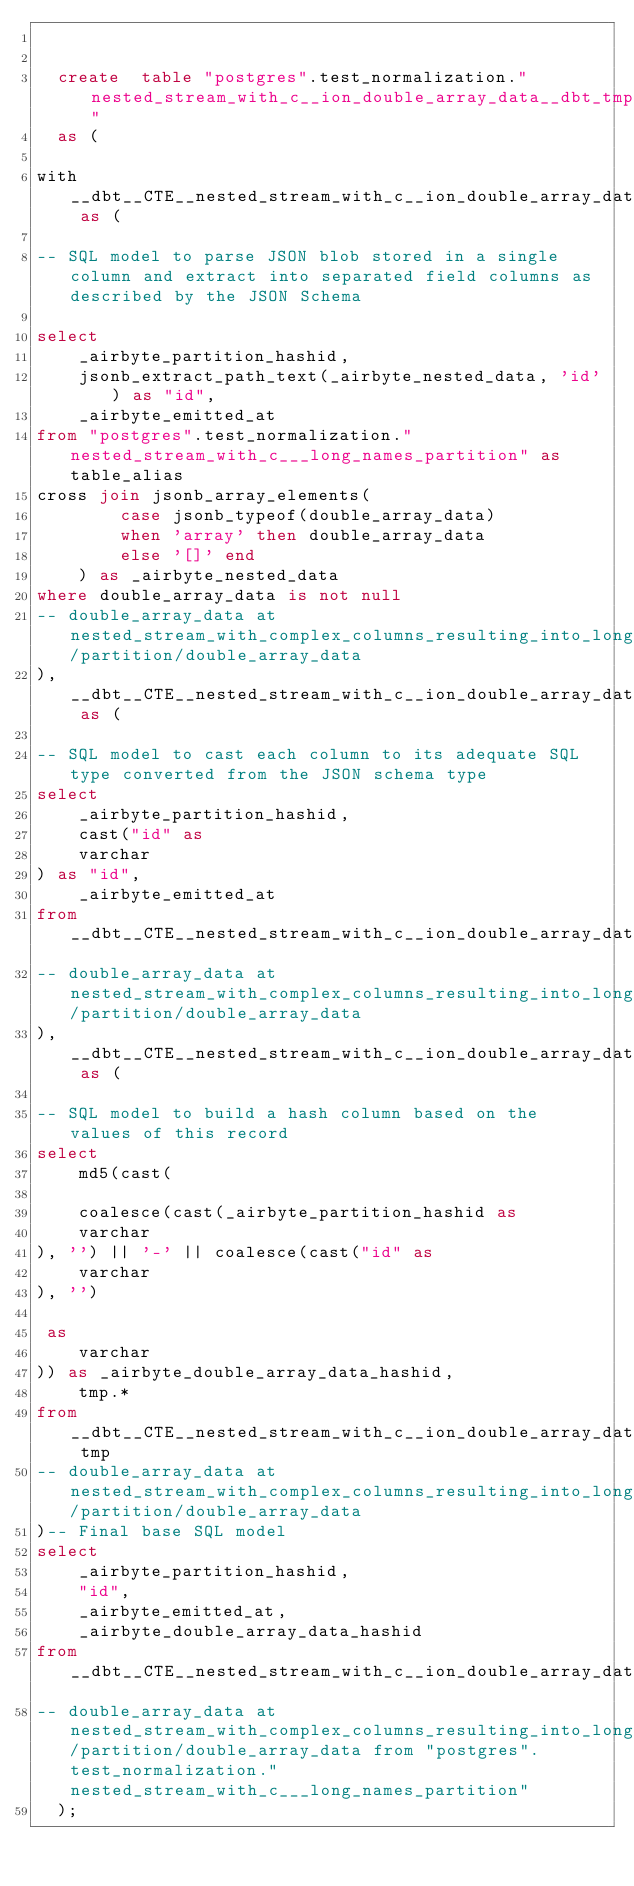<code> <loc_0><loc_0><loc_500><loc_500><_SQL_>

  create  table "postgres".test_normalization."nested_stream_with_c__ion_double_array_data__dbt_tmp"
  as (
    
with __dbt__CTE__nested_stream_with_c__ion_double_array_data_ab1 as (

-- SQL model to parse JSON blob stored in a single column and extract into separated field columns as described by the JSON Schema

select
    _airbyte_partition_hashid,
    jsonb_extract_path_text(_airbyte_nested_data, 'id') as "id",
    _airbyte_emitted_at
from "postgres".test_normalization."nested_stream_with_c___long_names_partition" as table_alias
cross join jsonb_array_elements(
        case jsonb_typeof(double_array_data)
        when 'array' then double_array_data
        else '[]' end
    ) as _airbyte_nested_data
where double_array_data is not null
-- double_array_data at nested_stream_with_complex_columns_resulting_into_long_names/partition/double_array_data
),  __dbt__CTE__nested_stream_with_c__ion_double_array_data_ab2 as (

-- SQL model to cast each column to its adequate SQL type converted from the JSON schema type
select
    _airbyte_partition_hashid,
    cast("id" as 
    varchar
) as "id",
    _airbyte_emitted_at
from __dbt__CTE__nested_stream_with_c__ion_double_array_data_ab1
-- double_array_data at nested_stream_with_complex_columns_resulting_into_long_names/partition/double_array_data
),  __dbt__CTE__nested_stream_with_c__ion_double_array_data_ab3 as (

-- SQL model to build a hash column based on the values of this record
select
    md5(cast(
    
    coalesce(cast(_airbyte_partition_hashid as 
    varchar
), '') || '-' || coalesce(cast("id" as 
    varchar
), '')

 as 
    varchar
)) as _airbyte_double_array_data_hashid,
    tmp.*
from __dbt__CTE__nested_stream_with_c__ion_double_array_data_ab2 tmp
-- double_array_data at nested_stream_with_complex_columns_resulting_into_long_names/partition/double_array_data
)-- Final base SQL model
select
    _airbyte_partition_hashid,
    "id",
    _airbyte_emitted_at,
    _airbyte_double_array_data_hashid
from __dbt__CTE__nested_stream_with_c__ion_double_array_data_ab3
-- double_array_data at nested_stream_with_complex_columns_resulting_into_long_names/partition/double_array_data from "postgres".test_normalization."nested_stream_with_c___long_names_partition"
  );</code> 